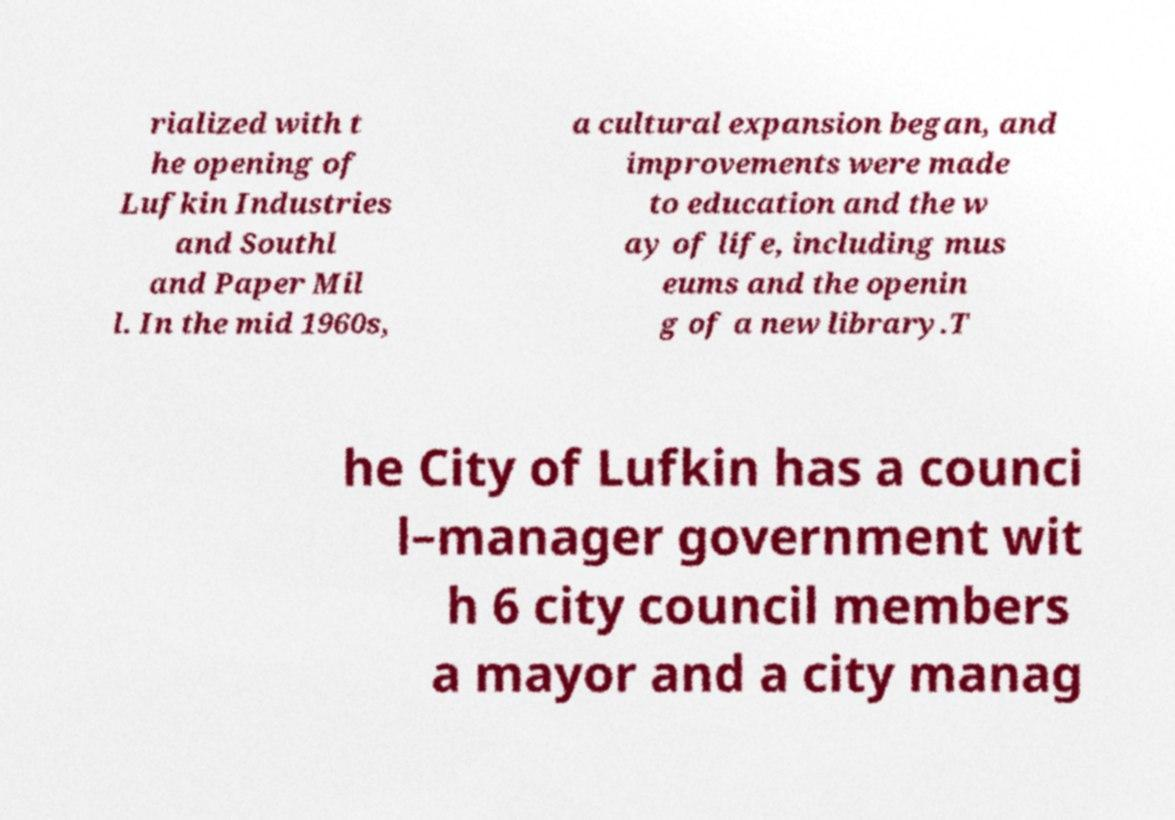For documentation purposes, I need the text within this image transcribed. Could you provide that? rialized with t he opening of Lufkin Industries and Southl and Paper Mil l. In the mid 1960s, a cultural expansion began, and improvements were made to education and the w ay of life, including mus eums and the openin g of a new library.T he City of Lufkin has a counci l–manager government wit h 6 city council members a mayor and a city manag 